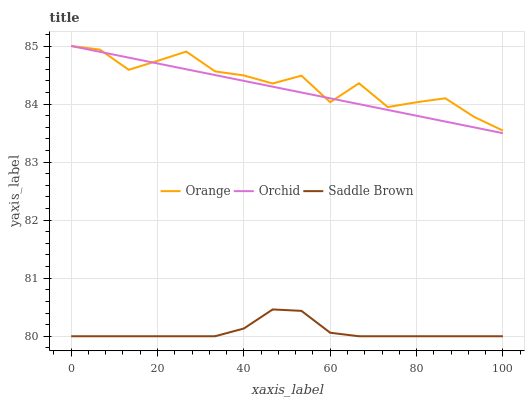Does Saddle Brown have the minimum area under the curve?
Answer yes or no. Yes. Does Orange have the maximum area under the curve?
Answer yes or no. Yes. Does Orchid have the minimum area under the curve?
Answer yes or no. No. Does Orchid have the maximum area under the curve?
Answer yes or no. No. Is Orchid the smoothest?
Answer yes or no. Yes. Is Orange the roughest?
Answer yes or no. Yes. Is Saddle Brown the smoothest?
Answer yes or no. No. Is Saddle Brown the roughest?
Answer yes or no. No. Does Saddle Brown have the lowest value?
Answer yes or no. Yes. Does Orchid have the lowest value?
Answer yes or no. No. Does Orchid have the highest value?
Answer yes or no. Yes. Does Saddle Brown have the highest value?
Answer yes or no. No. Is Saddle Brown less than Orange?
Answer yes or no. Yes. Is Orchid greater than Saddle Brown?
Answer yes or no. Yes. Does Orange intersect Orchid?
Answer yes or no. Yes. Is Orange less than Orchid?
Answer yes or no. No. Is Orange greater than Orchid?
Answer yes or no. No. Does Saddle Brown intersect Orange?
Answer yes or no. No. 